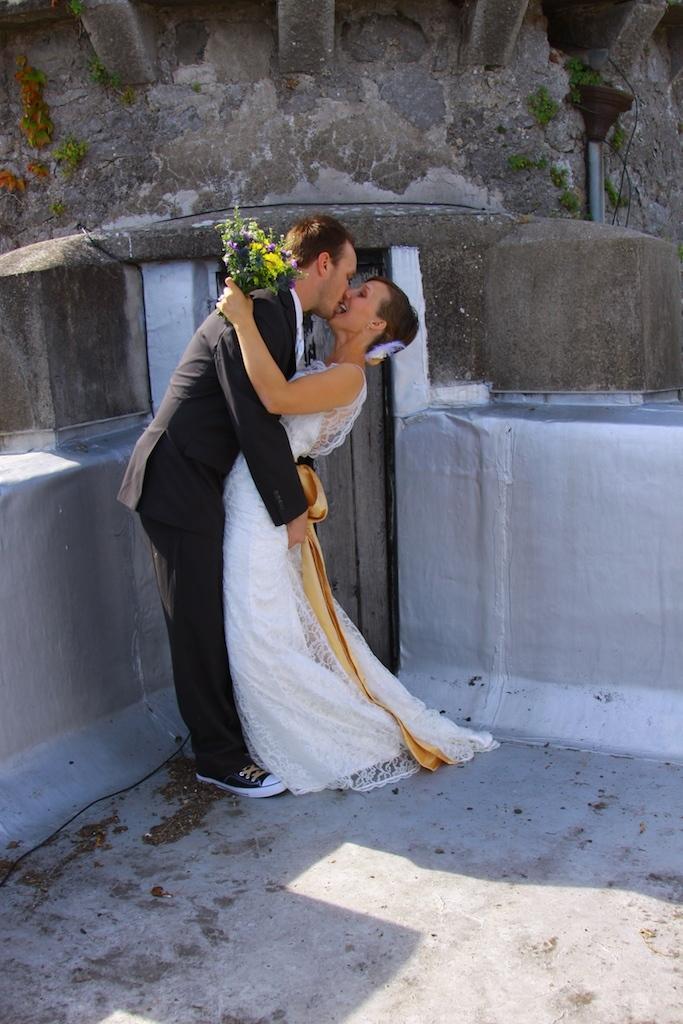How would you summarize this image in a sentence or two? In the image we can see there are two people hugging each other. A woman is holding a flower bouquet and the man is holding a woman in his arms. 